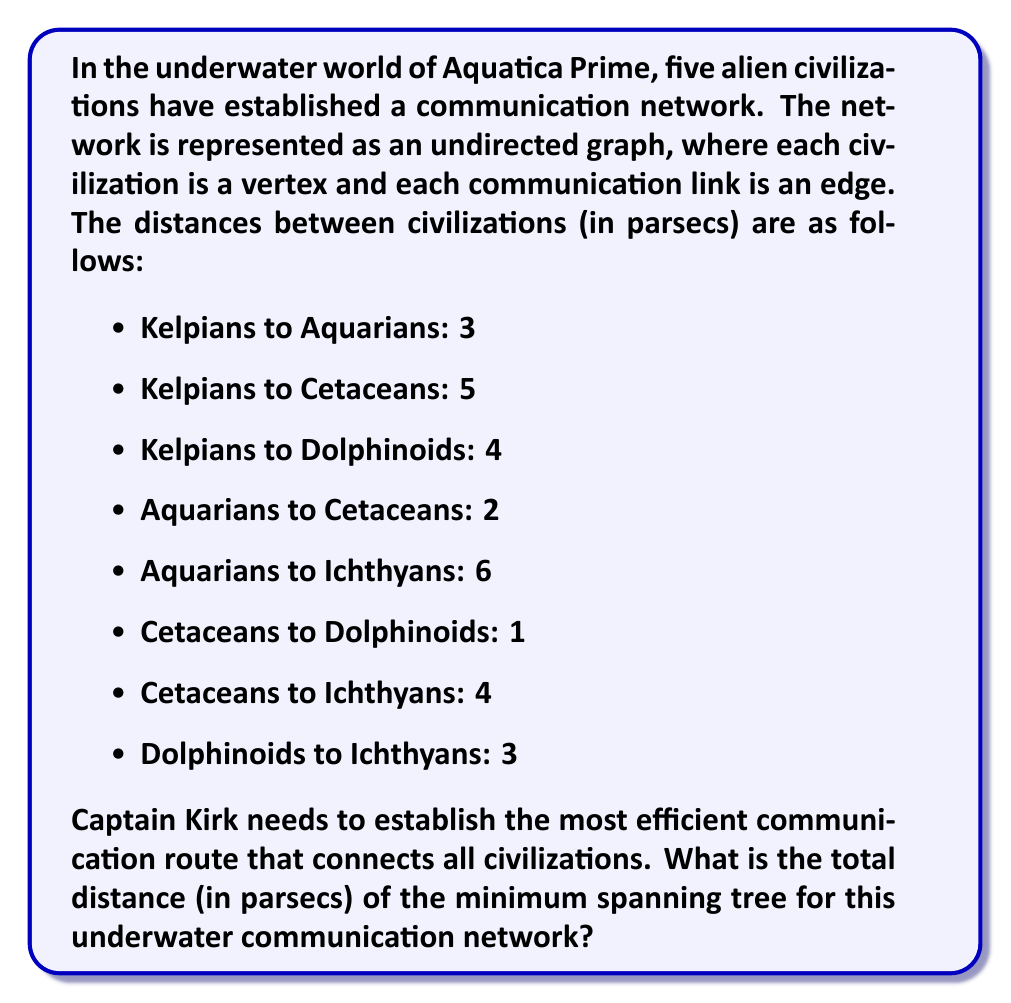Solve this math problem. To solve this problem, we'll use Kruskal's algorithm to find the minimum spanning tree (MST) of the given graph. This algorithm is particularly suitable for our underwater network as it finds the MST by selecting the edges with the smallest weights first.

Let's follow these steps:

1) First, list all edges in ascending order of their weights (distances):
   Cetaceans - Dolphinoids: 1
   Aquarians - Cetaceans: 2
   Kelpians - Aquarians: 3
   Dolphinoids - Ichthyans: 3
   Kelpians - Dolphinoids: 4
   Cetaceans - Ichthyans: 4
   Kelpians - Cetaceans: 5
   Aquarians - Ichthyans: 6

2) Now, we'll add edges to our MST, starting with the smallest, as long as they don't create a cycle:

   a) Cetaceans - Dolphinoids (1): Add (total = 1)
   b) Aquarians - Cetaceans (2): Add (total = 3)
   c) Kelpians - Aquarians (3): Add (total = 6)
   d) Dolphinoids - Ichthyans (3): Add (total = 9)

3) At this point, we've connected all five civilizations without creating any cycles, so we stop.

The resulting minimum spanning tree has a total distance of 9 parsecs.

This solution ensures that all civilizations are connected with the minimum total distance, allowing for efficient communication across the underwater network of Aquatica Prime.
Answer: The total distance of the minimum spanning tree for the underwater communication network is 9 parsecs. 